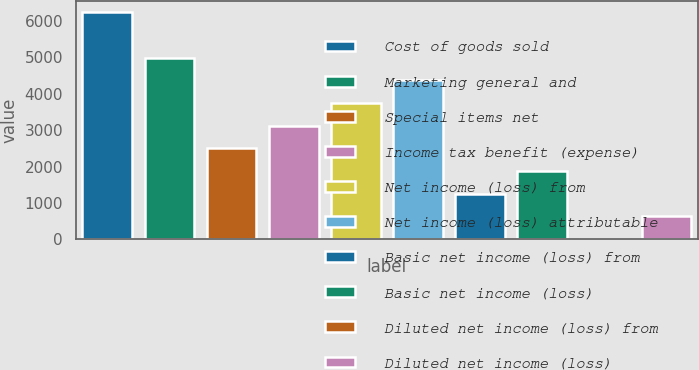Convert chart to OTSL. <chart><loc_0><loc_0><loc_500><loc_500><bar_chart><fcel>Cost of goods sold<fcel>Marketing general and<fcel>Special items net<fcel>Income tax benefit (expense)<fcel>Net income (loss) from<fcel>Net income (loss) attributable<fcel>Basic net income (loss) from<fcel>Basic net income (loss)<fcel>Diluted net income (loss) from<fcel>Diluted net income (loss)<nl><fcel>6238.9<fcel>4992.39<fcel>2499.39<fcel>3122.64<fcel>3745.89<fcel>4369.14<fcel>1252.89<fcel>1876.14<fcel>6.39<fcel>629.64<nl></chart> 